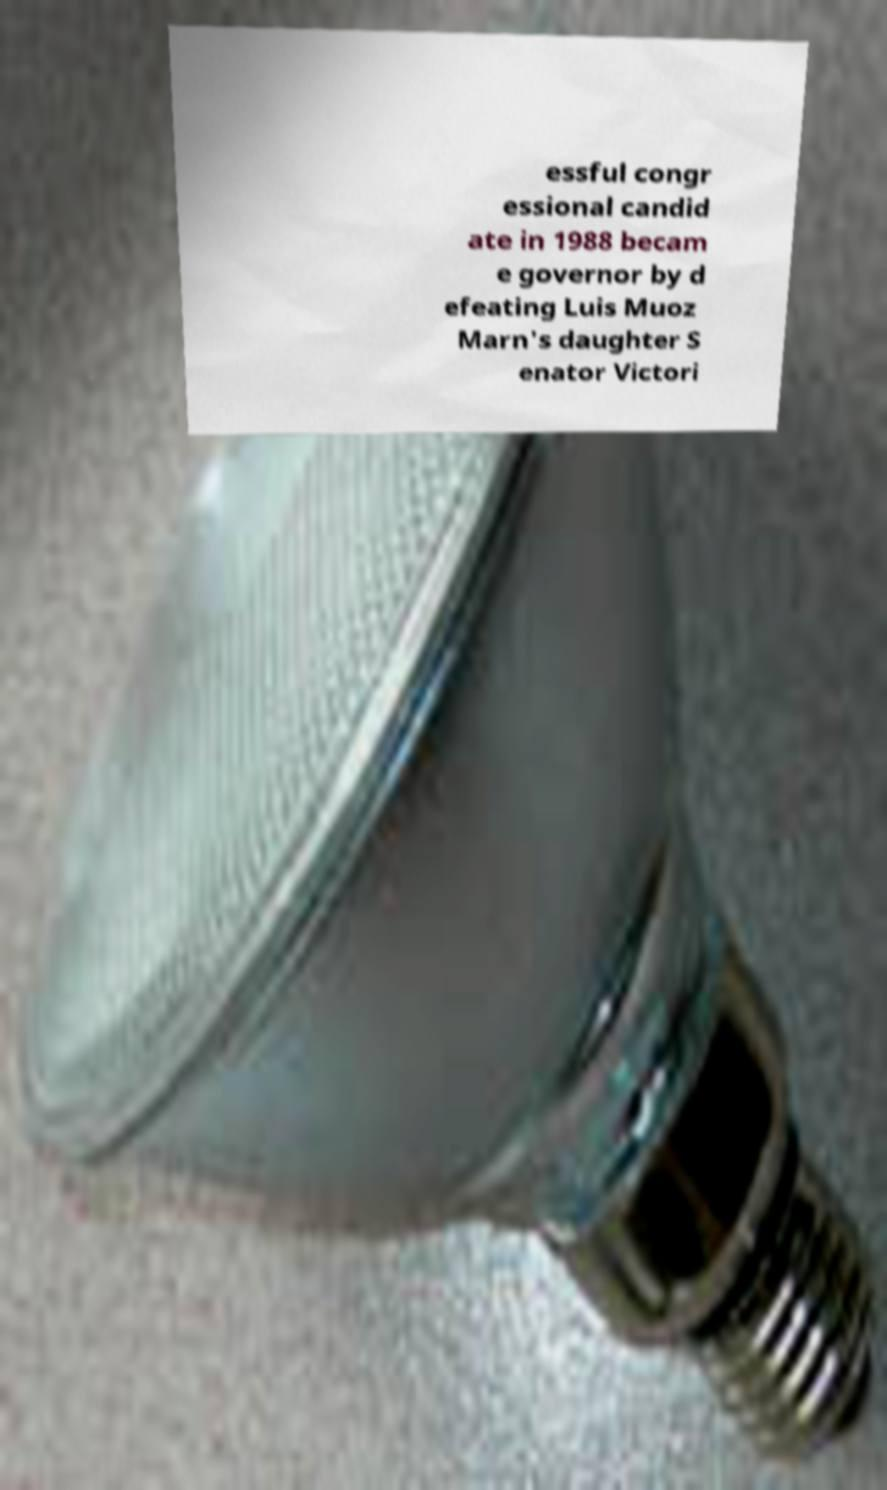What messages or text are displayed in this image? I need them in a readable, typed format. essful congr essional candid ate in 1988 becam e governor by d efeating Luis Muoz Marn's daughter S enator Victori 